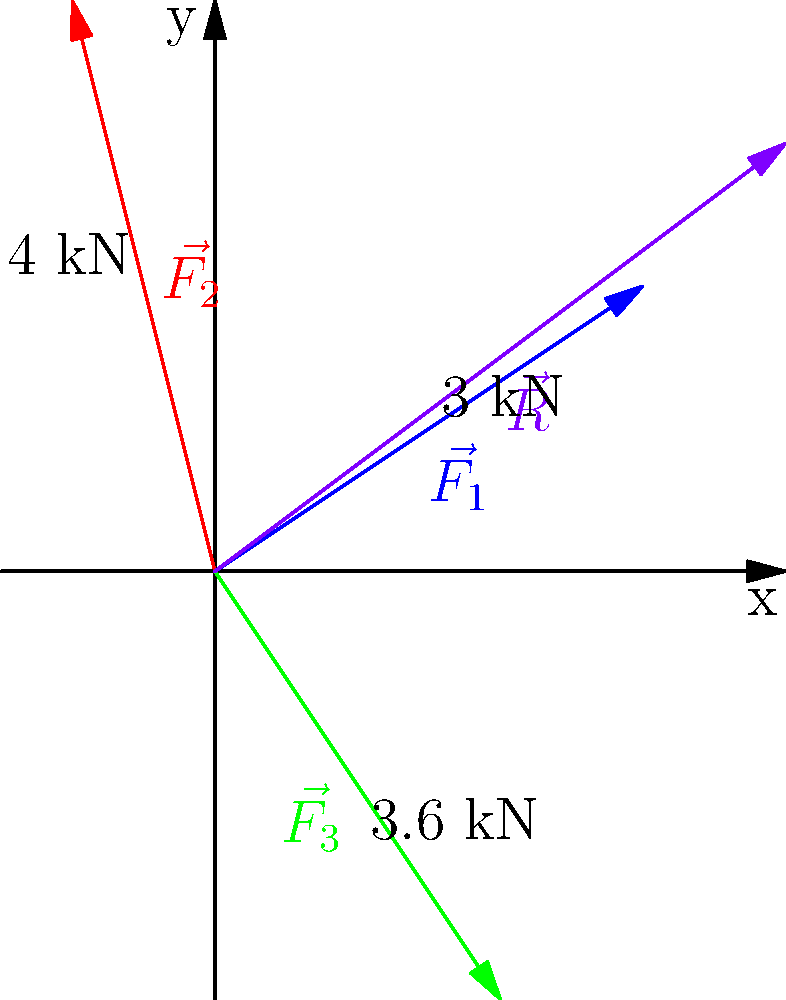In a rock deformation scenario, three force vectors are acting on a metamorphic rock sample: $\vec{F_1} = 3\hat{i} + 2\hat{j}$ kN, $\vec{F_2} = -\hat{i} + 4\hat{j}$ kN, and $\vec{F_3} = 2\hat{i} - 3\hat{j}$ kN. Calculate the magnitude and direction (in degrees from the positive x-axis) of the resultant force vector $\vec{R}$. To solve this problem, we'll follow these steps:

1. Find the resultant vector by adding the three force vectors:
   $\vec{R} = \vec{F_1} + \vec{F_2} + \vec{F_3}$
   $\vec{R} = (3\hat{i} + 2\hat{j}) + (-\hat{i} + 4\hat{j}) + (2\hat{i} - 3\hat{j})$
   $\vec{R} = (3 - 1 + 2)\hat{i} + (2 + 4 - 3)\hat{j}$
   $\vec{R} = 4\hat{i} + 3\hat{j}$

2. Calculate the magnitude of the resultant vector using the Pythagorean theorem:
   $|\vec{R}| = \sqrt{R_x^2 + R_y^2} = \sqrt{4^2 + 3^2} = \sqrt{16 + 9} = \sqrt{25} = 5$ kN

3. Calculate the direction angle $\theta$ using the arctangent function:
   $\theta = \tan^{-1}(\frac{R_y}{R_x}) = \tan^{-1}(\frac{3}{4})$
   $\theta \approx 36.87°$

Therefore, the resultant force vector has a magnitude of 5 kN and acts at an angle of approximately 36.87° from the positive x-axis.
Answer: Magnitude: 5 kN, Direction: 36.87° 